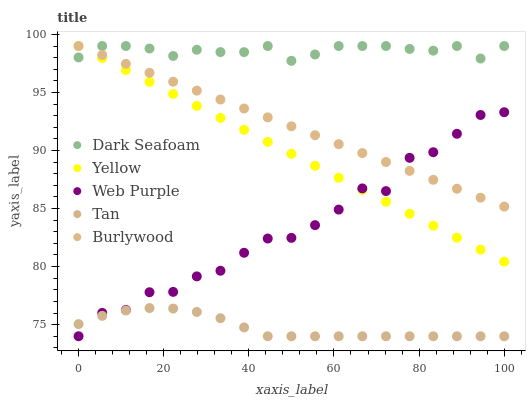Does Tan have the minimum area under the curve?
Answer yes or no. Yes. Does Dark Seafoam have the maximum area under the curve?
Answer yes or no. Yes. Does Dark Seafoam have the minimum area under the curve?
Answer yes or no. No. Does Tan have the maximum area under the curve?
Answer yes or no. No. Is Yellow the smoothest?
Answer yes or no. Yes. Is Web Purple the roughest?
Answer yes or no. Yes. Is Dark Seafoam the smoothest?
Answer yes or no. No. Is Dark Seafoam the roughest?
Answer yes or no. No. Does Tan have the lowest value?
Answer yes or no. Yes. Does Dark Seafoam have the lowest value?
Answer yes or no. No. Does Yellow have the highest value?
Answer yes or no. Yes. Does Tan have the highest value?
Answer yes or no. No. Is Web Purple less than Dark Seafoam?
Answer yes or no. Yes. Is Burlywood greater than Tan?
Answer yes or no. Yes. Does Yellow intersect Web Purple?
Answer yes or no. Yes. Is Yellow less than Web Purple?
Answer yes or no. No. Is Yellow greater than Web Purple?
Answer yes or no. No. Does Web Purple intersect Dark Seafoam?
Answer yes or no. No. 